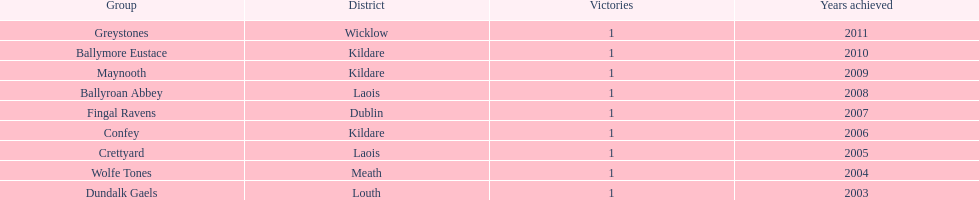Prior to crettyard, which team emerged as the winner? Wolfe Tones. 